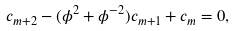Convert formula to latex. <formula><loc_0><loc_0><loc_500><loc_500>c _ { m + 2 } - ( \phi ^ { 2 } + \phi ^ { - 2 } ) c _ { m + 1 } + c _ { m } = 0 ,</formula> 